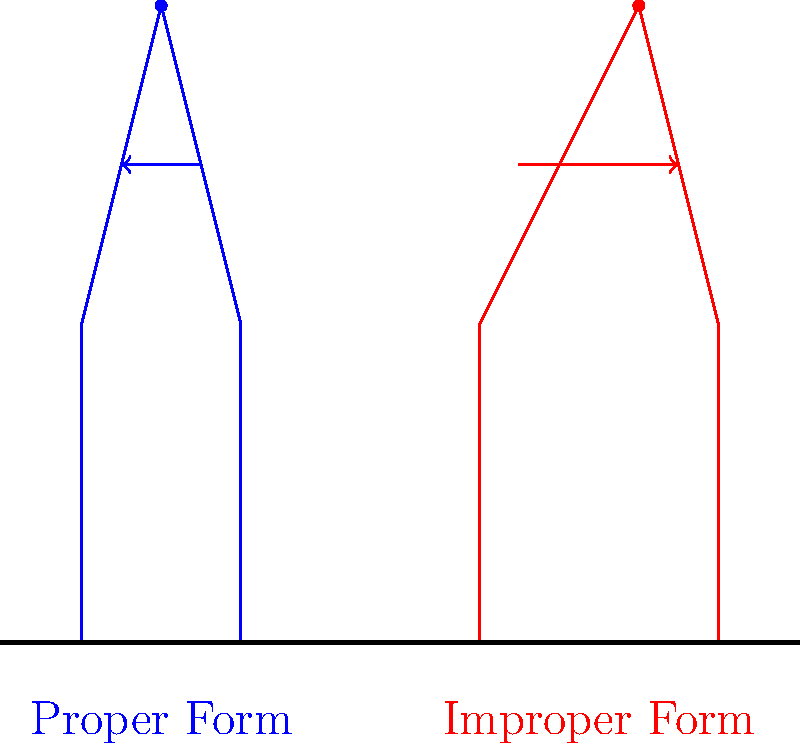As someone who understands the importance of proper technique to avoid injury, especially during financially stressful times when healthcare costs can be a burden, which biomechanical principle is most crucial when lifting weights, as illustrated in the diagram? To answer this question, let's analyze the biomechanical principles illustrated in the diagram:

1. The blue stick figure represents proper form, while the red stick figure shows improper form.

2. In the proper form:
   a. The back is straight and aligned.
   b. The weight is kept close to the body.
   c. The knees are bent, utilizing leg muscles.
   d. The head is in a neutral position.

3. In the improper form:
   a. The back is curved (rounded).
   b. The weight is far from the body.
   c. The knees are less bent, putting more strain on the back.
   d. The head is tilted back.

4. The most crucial biomechanical principle illustrated here is maintaining a neutral spine position (keeping the back straight).

5. A neutral spine position:
   a. Distributes the load evenly across the vertebrae.
   b. Minimizes shear forces on the intervertebral discs.
   c. Reduces the risk of herniation or other back injuries.

6. Proper form also demonstrates the importance of using larger muscle groups (like legs) instead of smaller, more vulnerable muscles (like those in the lower back).

7. Keeping the weight close to the body reduces the moment arm, decreasing the torque on the spine and requiring less muscle force to lift the weight.

Given the financial implications of potential injuries, especially in light of the 2008 crisis aftermath, maintaining a neutral spine is the most crucial principle to prevent costly back injuries.
Answer: Maintaining a neutral spine position 